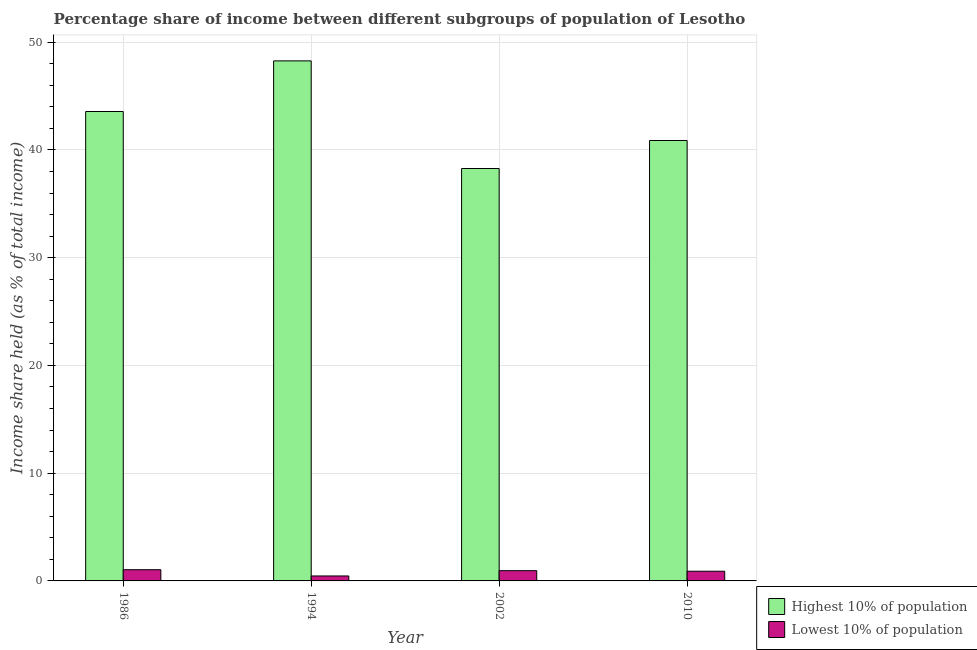Are the number of bars per tick equal to the number of legend labels?
Provide a succinct answer. Yes. How many bars are there on the 1st tick from the left?
Your response must be concise. 2. What is the income share held by highest 10% of the population in 2010?
Ensure brevity in your answer.  40.88. Across all years, what is the maximum income share held by highest 10% of the population?
Your answer should be very brief. 48.27. Across all years, what is the minimum income share held by lowest 10% of the population?
Provide a succinct answer. 0.46. In which year was the income share held by highest 10% of the population minimum?
Offer a terse response. 2002. What is the total income share held by highest 10% of the population in the graph?
Provide a short and direct response. 171. What is the difference between the income share held by highest 10% of the population in 1986 and that in 1994?
Your answer should be compact. -4.7. What is the difference between the income share held by lowest 10% of the population in 1994 and the income share held by highest 10% of the population in 2010?
Give a very brief answer. -0.44. What is the average income share held by highest 10% of the population per year?
Offer a terse response. 42.75. What is the ratio of the income share held by lowest 10% of the population in 1986 to that in 2002?
Provide a short and direct response. 1.09. What is the difference between the highest and the second highest income share held by lowest 10% of the population?
Make the answer very short. 0.09. What is the difference between the highest and the lowest income share held by highest 10% of the population?
Ensure brevity in your answer.  9.99. In how many years, is the income share held by lowest 10% of the population greater than the average income share held by lowest 10% of the population taken over all years?
Offer a terse response. 3. Is the sum of the income share held by lowest 10% of the population in 1986 and 2010 greater than the maximum income share held by highest 10% of the population across all years?
Offer a terse response. Yes. What does the 2nd bar from the left in 2010 represents?
Make the answer very short. Lowest 10% of population. What does the 2nd bar from the right in 1994 represents?
Provide a short and direct response. Highest 10% of population. Are all the bars in the graph horizontal?
Your response must be concise. No. How many years are there in the graph?
Offer a terse response. 4. What is the difference between two consecutive major ticks on the Y-axis?
Your answer should be compact. 10. Are the values on the major ticks of Y-axis written in scientific E-notation?
Provide a succinct answer. No. Does the graph contain any zero values?
Offer a terse response. No. Where does the legend appear in the graph?
Keep it short and to the point. Bottom right. How many legend labels are there?
Your answer should be very brief. 2. What is the title of the graph?
Give a very brief answer. Percentage share of income between different subgroups of population of Lesotho. What is the label or title of the Y-axis?
Your answer should be very brief. Income share held (as % of total income). What is the Income share held (as % of total income) of Highest 10% of population in 1986?
Keep it short and to the point. 43.57. What is the Income share held (as % of total income) in Highest 10% of population in 1994?
Offer a very short reply. 48.27. What is the Income share held (as % of total income) in Lowest 10% of population in 1994?
Offer a very short reply. 0.46. What is the Income share held (as % of total income) in Highest 10% of population in 2002?
Provide a short and direct response. 38.28. What is the Income share held (as % of total income) in Highest 10% of population in 2010?
Ensure brevity in your answer.  40.88. Across all years, what is the maximum Income share held (as % of total income) in Highest 10% of population?
Your response must be concise. 48.27. Across all years, what is the maximum Income share held (as % of total income) in Lowest 10% of population?
Ensure brevity in your answer.  1.04. Across all years, what is the minimum Income share held (as % of total income) of Highest 10% of population?
Your answer should be very brief. 38.28. Across all years, what is the minimum Income share held (as % of total income) of Lowest 10% of population?
Your response must be concise. 0.46. What is the total Income share held (as % of total income) of Highest 10% of population in the graph?
Offer a very short reply. 171. What is the total Income share held (as % of total income) of Lowest 10% of population in the graph?
Offer a very short reply. 3.35. What is the difference between the Income share held (as % of total income) of Lowest 10% of population in 1986 and that in 1994?
Make the answer very short. 0.58. What is the difference between the Income share held (as % of total income) of Highest 10% of population in 1986 and that in 2002?
Give a very brief answer. 5.29. What is the difference between the Income share held (as % of total income) in Lowest 10% of population in 1986 and that in 2002?
Ensure brevity in your answer.  0.09. What is the difference between the Income share held (as % of total income) of Highest 10% of population in 1986 and that in 2010?
Your response must be concise. 2.69. What is the difference between the Income share held (as % of total income) of Lowest 10% of population in 1986 and that in 2010?
Make the answer very short. 0.14. What is the difference between the Income share held (as % of total income) of Highest 10% of population in 1994 and that in 2002?
Make the answer very short. 9.99. What is the difference between the Income share held (as % of total income) of Lowest 10% of population in 1994 and that in 2002?
Your answer should be very brief. -0.49. What is the difference between the Income share held (as % of total income) in Highest 10% of population in 1994 and that in 2010?
Make the answer very short. 7.39. What is the difference between the Income share held (as % of total income) of Lowest 10% of population in 1994 and that in 2010?
Provide a short and direct response. -0.44. What is the difference between the Income share held (as % of total income) of Lowest 10% of population in 2002 and that in 2010?
Your response must be concise. 0.05. What is the difference between the Income share held (as % of total income) in Highest 10% of population in 1986 and the Income share held (as % of total income) in Lowest 10% of population in 1994?
Keep it short and to the point. 43.11. What is the difference between the Income share held (as % of total income) in Highest 10% of population in 1986 and the Income share held (as % of total income) in Lowest 10% of population in 2002?
Offer a very short reply. 42.62. What is the difference between the Income share held (as % of total income) of Highest 10% of population in 1986 and the Income share held (as % of total income) of Lowest 10% of population in 2010?
Give a very brief answer. 42.67. What is the difference between the Income share held (as % of total income) of Highest 10% of population in 1994 and the Income share held (as % of total income) of Lowest 10% of population in 2002?
Your answer should be very brief. 47.32. What is the difference between the Income share held (as % of total income) of Highest 10% of population in 1994 and the Income share held (as % of total income) of Lowest 10% of population in 2010?
Ensure brevity in your answer.  47.37. What is the difference between the Income share held (as % of total income) in Highest 10% of population in 2002 and the Income share held (as % of total income) in Lowest 10% of population in 2010?
Provide a short and direct response. 37.38. What is the average Income share held (as % of total income) in Highest 10% of population per year?
Offer a very short reply. 42.75. What is the average Income share held (as % of total income) of Lowest 10% of population per year?
Make the answer very short. 0.84. In the year 1986, what is the difference between the Income share held (as % of total income) of Highest 10% of population and Income share held (as % of total income) of Lowest 10% of population?
Keep it short and to the point. 42.53. In the year 1994, what is the difference between the Income share held (as % of total income) in Highest 10% of population and Income share held (as % of total income) in Lowest 10% of population?
Your answer should be compact. 47.81. In the year 2002, what is the difference between the Income share held (as % of total income) of Highest 10% of population and Income share held (as % of total income) of Lowest 10% of population?
Keep it short and to the point. 37.33. In the year 2010, what is the difference between the Income share held (as % of total income) in Highest 10% of population and Income share held (as % of total income) in Lowest 10% of population?
Give a very brief answer. 39.98. What is the ratio of the Income share held (as % of total income) in Highest 10% of population in 1986 to that in 1994?
Give a very brief answer. 0.9. What is the ratio of the Income share held (as % of total income) in Lowest 10% of population in 1986 to that in 1994?
Ensure brevity in your answer.  2.26. What is the ratio of the Income share held (as % of total income) in Highest 10% of population in 1986 to that in 2002?
Make the answer very short. 1.14. What is the ratio of the Income share held (as % of total income) of Lowest 10% of population in 1986 to that in 2002?
Offer a very short reply. 1.09. What is the ratio of the Income share held (as % of total income) in Highest 10% of population in 1986 to that in 2010?
Provide a short and direct response. 1.07. What is the ratio of the Income share held (as % of total income) in Lowest 10% of population in 1986 to that in 2010?
Your answer should be very brief. 1.16. What is the ratio of the Income share held (as % of total income) in Highest 10% of population in 1994 to that in 2002?
Your answer should be compact. 1.26. What is the ratio of the Income share held (as % of total income) in Lowest 10% of population in 1994 to that in 2002?
Offer a terse response. 0.48. What is the ratio of the Income share held (as % of total income) in Highest 10% of population in 1994 to that in 2010?
Keep it short and to the point. 1.18. What is the ratio of the Income share held (as % of total income) in Lowest 10% of population in 1994 to that in 2010?
Make the answer very short. 0.51. What is the ratio of the Income share held (as % of total income) in Highest 10% of population in 2002 to that in 2010?
Provide a short and direct response. 0.94. What is the ratio of the Income share held (as % of total income) of Lowest 10% of population in 2002 to that in 2010?
Your answer should be very brief. 1.06. What is the difference between the highest and the second highest Income share held (as % of total income) of Lowest 10% of population?
Ensure brevity in your answer.  0.09. What is the difference between the highest and the lowest Income share held (as % of total income) of Highest 10% of population?
Offer a very short reply. 9.99. What is the difference between the highest and the lowest Income share held (as % of total income) in Lowest 10% of population?
Provide a short and direct response. 0.58. 